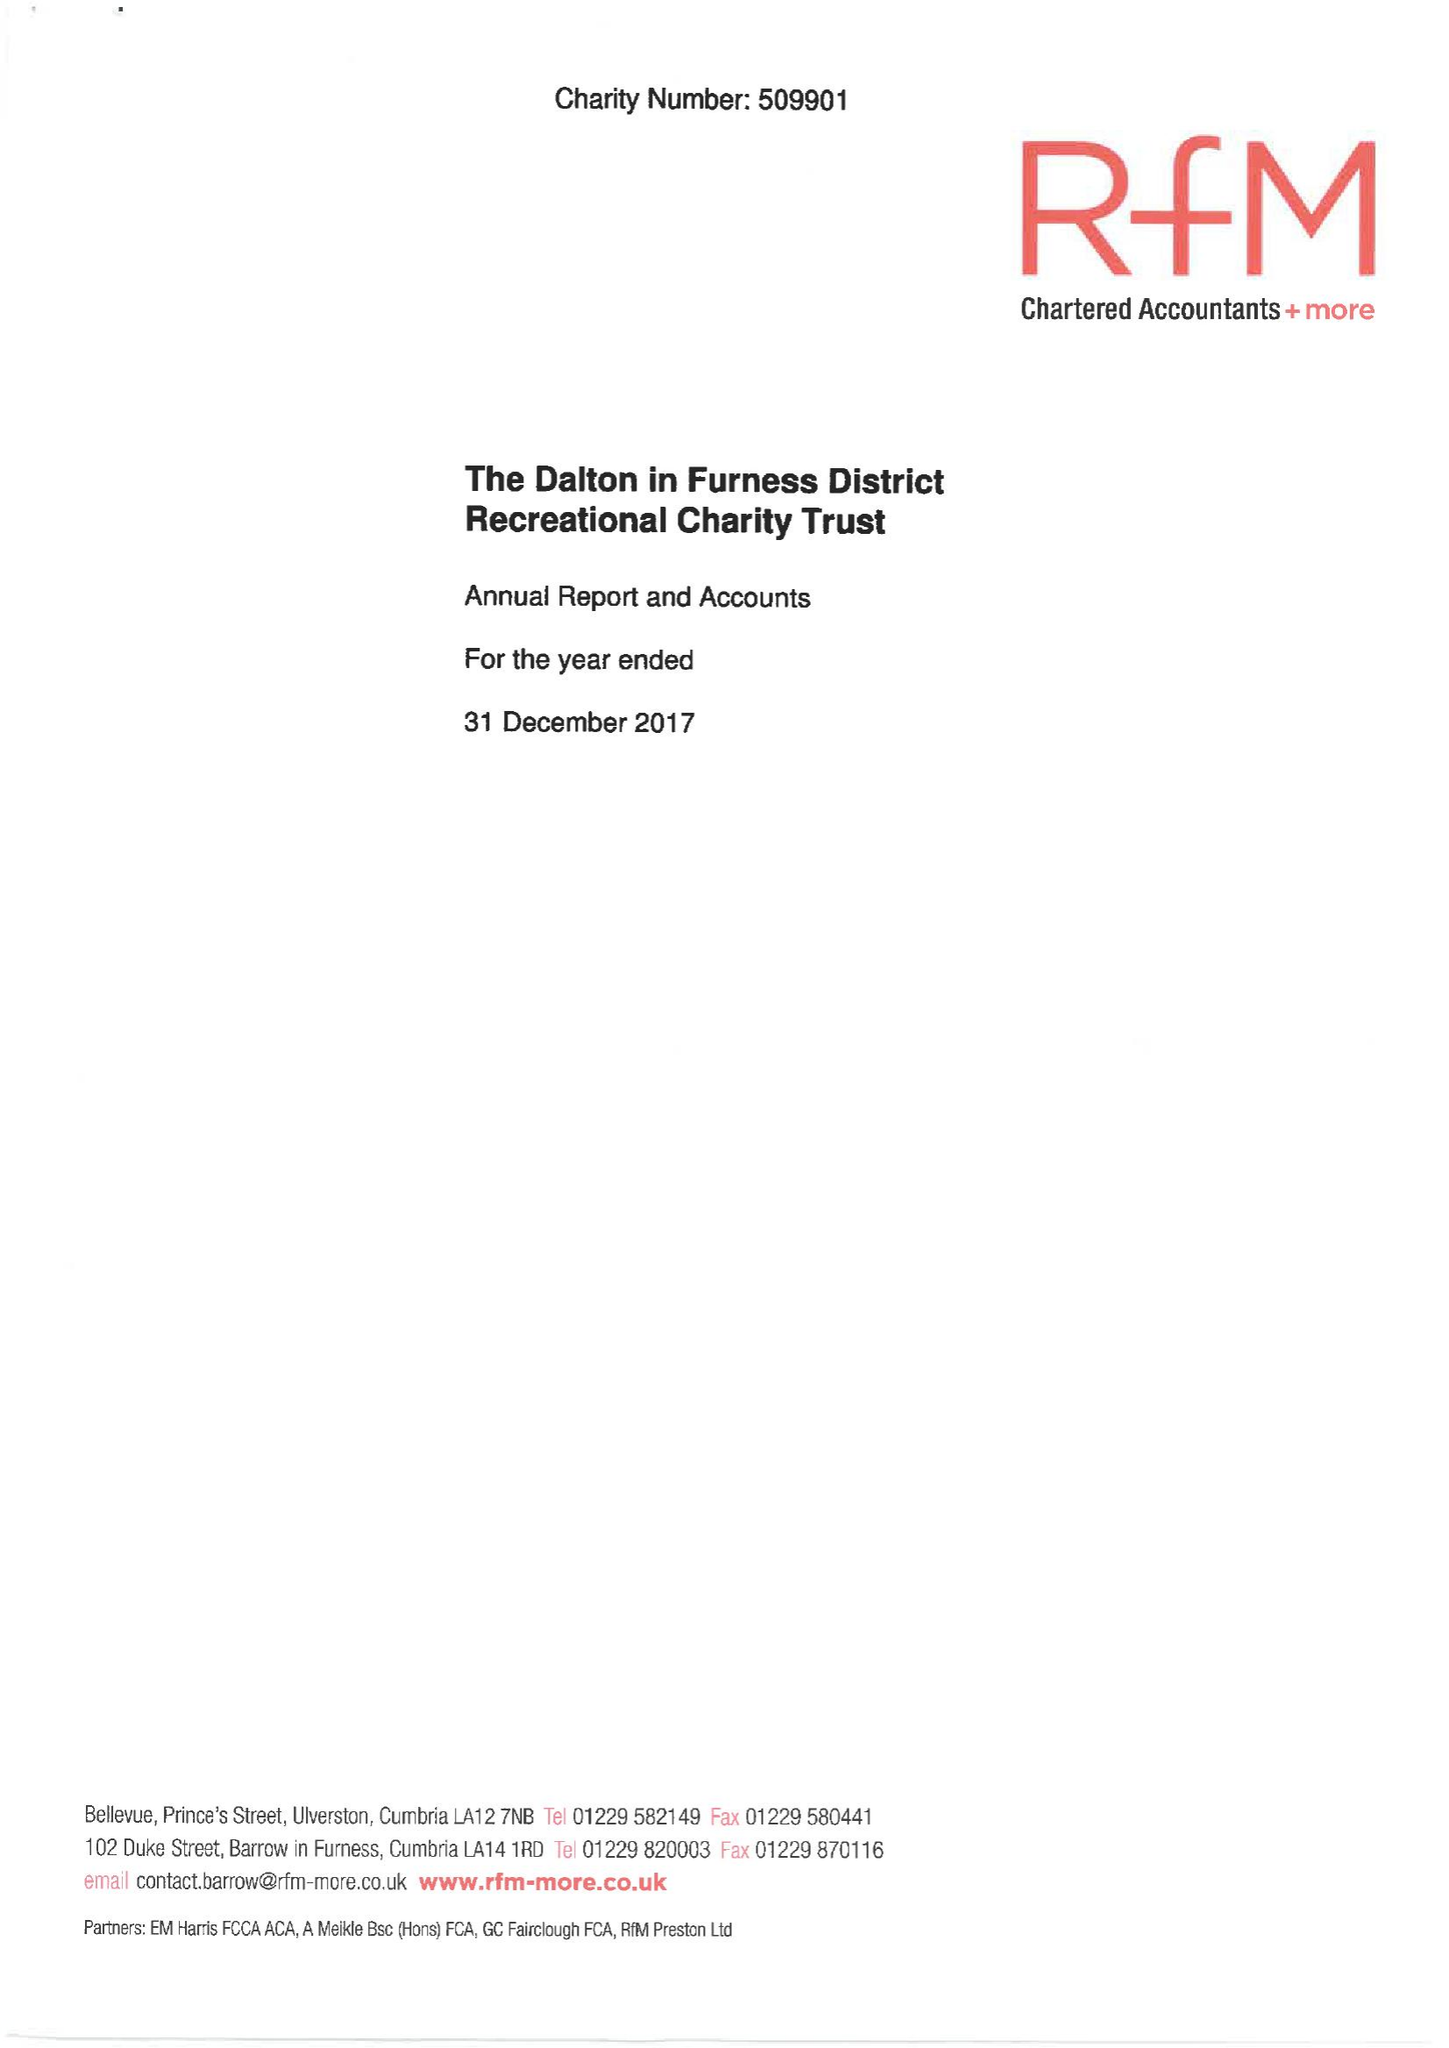What is the value for the address__postcode?
Answer the question using a single word or phrase. LA17 7XY 